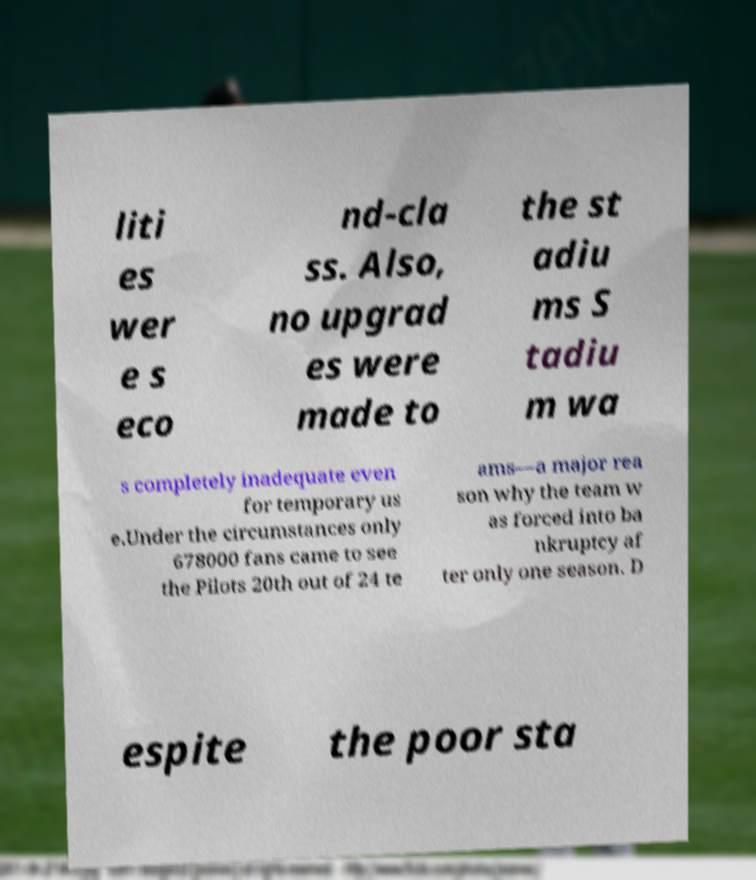Please read and relay the text visible in this image. What does it say? liti es wer e s eco nd-cla ss. Also, no upgrad es were made to the st adiu ms S tadiu m wa s completely inadequate even for temporary us e.Under the circumstances only 678000 fans came to see the Pilots 20th out of 24 te ams—a major rea son why the team w as forced into ba nkruptcy af ter only one season. D espite the poor sta 